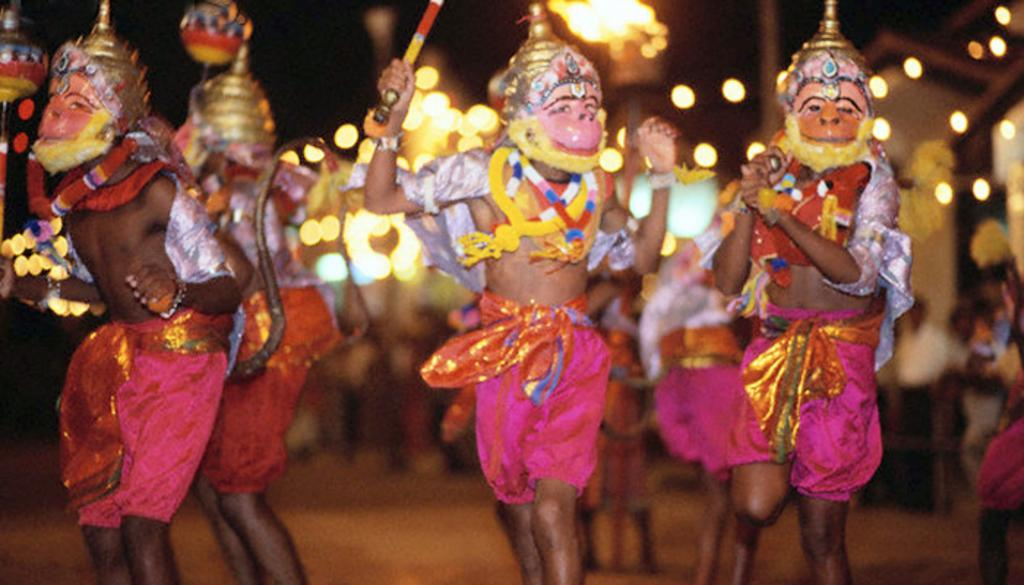What is happening in the center of the image? There is a group of persons performing in the center of the image. Where are the persons performing? The persons are on the road. What are the persons wearing while performing? The persons are wearing masks. Can you describe the background of the image? There are persons visible in the background of the image, and there are lights visible as well. Can you see any giants wearing a crown in the image? No, there are no giants or crowns present in the image. What type of vegetable is being used as a prop by the performers? There is no vegetable visible in the image; the performers are wearing masks and are not using any vegetables as props. 